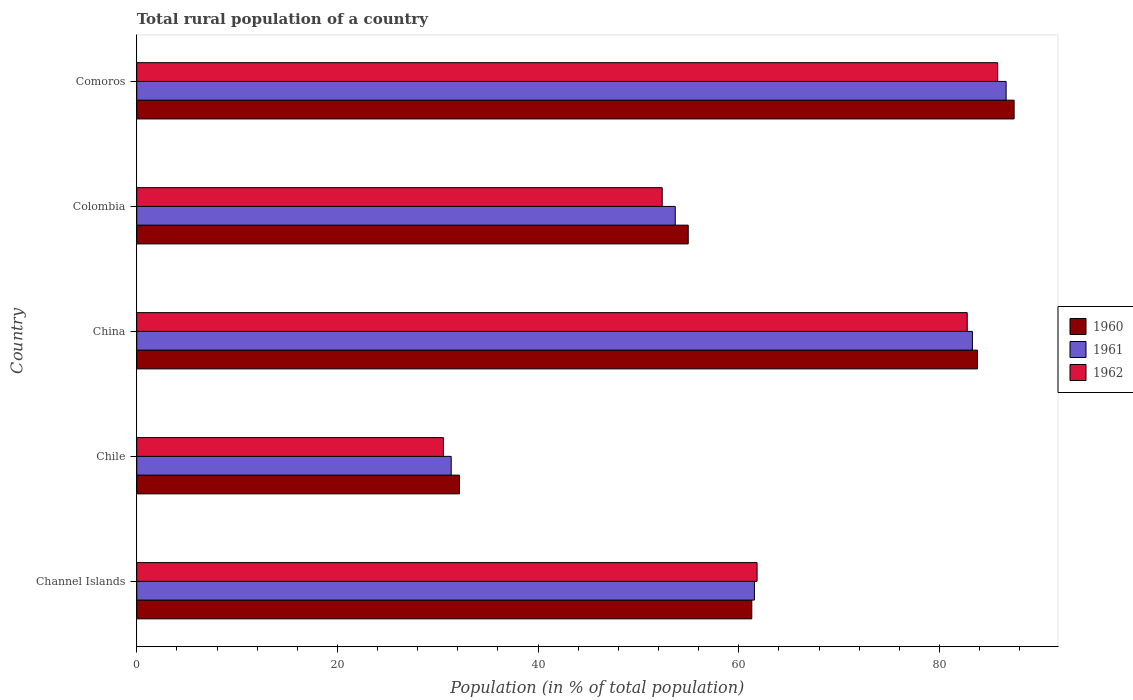Are the number of bars on each tick of the Y-axis equal?
Your answer should be compact. Yes. How many bars are there on the 2nd tick from the top?
Offer a very short reply. 3. How many bars are there on the 5th tick from the bottom?
Ensure brevity in your answer.  3. What is the label of the 2nd group of bars from the top?
Offer a terse response. Colombia. In how many cases, is the number of bars for a given country not equal to the number of legend labels?
Offer a very short reply. 0. What is the rural population in 1960 in China?
Provide a succinct answer. 83.8. Across all countries, what is the maximum rural population in 1960?
Ensure brevity in your answer.  87.45. Across all countries, what is the minimum rural population in 1960?
Provide a short and direct response. 32.16. In which country was the rural population in 1962 maximum?
Provide a short and direct response. Comoros. In which country was the rural population in 1961 minimum?
Your answer should be very brief. Chile. What is the total rural population in 1961 in the graph?
Keep it short and to the point. 316.52. What is the difference between the rural population in 1962 in Channel Islands and that in Colombia?
Your response must be concise. 9.46. What is the difference between the rural population in 1960 in China and the rural population in 1961 in Chile?
Your response must be concise. 52.46. What is the average rural population in 1960 per country?
Make the answer very short. 63.94. What is the difference between the rural population in 1960 and rural population in 1961 in Colombia?
Offer a terse response. 1.29. In how many countries, is the rural population in 1961 greater than 60 %?
Make the answer very short. 3. What is the ratio of the rural population in 1962 in Colombia to that in Comoros?
Your answer should be compact. 0.61. Is the rural population in 1962 in Chile less than that in Colombia?
Ensure brevity in your answer.  Yes. Is the difference between the rural population in 1960 in Channel Islands and Chile greater than the difference between the rural population in 1961 in Channel Islands and Chile?
Keep it short and to the point. No. What is the difference between the highest and the second highest rural population in 1961?
Your response must be concise. 3.36. What is the difference between the highest and the lowest rural population in 1960?
Your answer should be compact. 55.28. What is the difference between two consecutive major ticks on the X-axis?
Keep it short and to the point. 20. How many legend labels are there?
Offer a very short reply. 3. How are the legend labels stacked?
Your answer should be compact. Vertical. What is the title of the graph?
Your answer should be very brief. Total rural population of a country. What is the label or title of the X-axis?
Offer a very short reply. Population (in % of total population). What is the label or title of the Y-axis?
Your answer should be very brief. Country. What is the Population (in % of total population) of 1960 in Channel Islands?
Give a very brief answer. 61.3. What is the Population (in % of total population) of 1961 in Channel Islands?
Make the answer very short. 61.56. What is the Population (in % of total population) in 1962 in Channel Islands?
Offer a terse response. 61.83. What is the Population (in % of total population) of 1960 in Chile?
Make the answer very short. 32.16. What is the Population (in % of total population) in 1961 in Chile?
Offer a terse response. 31.34. What is the Population (in % of total population) of 1962 in Chile?
Your answer should be compact. 30.57. What is the Population (in % of total population) of 1960 in China?
Make the answer very short. 83.8. What is the Population (in % of total population) of 1961 in China?
Offer a very short reply. 83.29. What is the Population (in % of total population) in 1962 in China?
Provide a succinct answer. 82.77. What is the Population (in % of total population) of 1960 in Colombia?
Make the answer very short. 54.97. What is the Population (in % of total population) in 1961 in Colombia?
Offer a terse response. 53.67. What is the Population (in % of total population) of 1962 in Colombia?
Provide a short and direct response. 52.37. What is the Population (in % of total population) of 1960 in Comoros?
Offer a terse response. 87.45. What is the Population (in % of total population) in 1961 in Comoros?
Make the answer very short. 86.65. What is the Population (in % of total population) of 1962 in Comoros?
Offer a very short reply. 85.81. Across all countries, what is the maximum Population (in % of total population) of 1960?
Your response must be concise. 87.45. Across all countries, what is the maximum Population (in % of total population) of 1961?
Keep it short and to the point. 86.65. Across all countries, what is the maximum Population (in % of total population) in 1962?
Your response must be concise. 85.81. Across all countries, what is the minimum Population (in % of total population) in 1960?
Make the answer very short. 32.16. Across all countries, what is the minimum Population (in % of total population) in 1961?
Your response must be concise. 31.34. Across all countries, what is the minimum Population (in % of total population) in 1962?
Offer a very short reply. 30.57. What is the total Population (in % of total population) of 1960 in the graph?
Ensure brevity in your answer.  319.68. What is the total Population (in % of total population) of 1961 in the graph?
Offer a terse response. 316.52. What is the total Population (in % of total population) of 1962 in the graph?
Give a very brief answer. 313.35. What is the difference between the Population (in % of total population) in 1960 in Channel Islands and that in Chile?
Provide a succinct answer. 29.14. What is the difference between the Population (in % of total population) in 1961 in Channel Islands and that in Chile?
Keep it short and to the point. 30.22. What is the difference between the Population (in % of total population) in 1962 in Channel Islands and that in Chile?
Provide a succinct answer. 31.26. What is the difference between the Population (in % of total population) in 1960 in Channel Islands and that in China?
Offer a terse response. -22.5. What is the difference between the Population (in % of total population) of 1961 in Channel Islands and that in China?
Your response must be concise. -21.73. What is the difference between the Population (in % of total population) of 1962 in Channel Islands and that in China?
Keep it short and to the point. -20.95. What is the difference between the Population (in % of total population) in 1960 in Channel Islands and that in Colombia?
Ensure brevity in your answer.  6.33. What is the difference between the Population (in % of total population) of 1961 in Channel Islands and that in Colombia?
Offer a very short reply. 7.89. What is the difference between the Population (in % of total population) of 1962 in Channel Islands and that in Colombia?
Provide a succinct answer. 9.46. What is the difference between the Population (in % of total population) of 1960 in Channel Islands and that in Comoros?
Your answer should be very brief. -26.15. What is the difference between the Population (in % of total population) in 1961 in Channel Islands and that in Comoros?
Ensure brevity in your answer.  -25.09. What is the difference between the Population (in % of total population) in 1962 in Channel Islands and that in Comoros?
Provide a short and direct response. -23.98. What is the difference between the Population (in % of total population) in 1960 in Chile and that in China?
Offer a very short reply. -51.63. What is the difference between the Population (in % of total population) of 1961 in Chile and that in China?
Your answer should be very brief. -51.95. What is the difference between the Population (in % of total population) of 1962 in Chile and that in China?
Your answer should be very brief. -52.21. What is the difference between the Population (in % of total population) of 1960 in Chile and that in Colombia?
Make the answer very short. -22.8. What is the difference between the Population (in % of total population) in 1961 in Chile and that in Colombia?
Your response must be concise. -22.33. What is the difference between the Population (in % of total population) in 1962 in Chile and that in Colombia?
Your response must be concise. -21.81. What is the difference between the Population (in % of total population) of 1960 in Chile and that in Comoros?
Make the answer very short. -55.28. What is the difference between the Population (in % of total population) of 1961 in Chile and that in Comoros?
Ensure brevity in your answer.  -55.31. What is the difference between the Population (in % of total population) in 1962 in Chile and that in Comoros?
Keep it short and to the point. -55.25. What is the difference between the Population (in % of total population) in 1960 in China and that in Colombia?
Your answer should be compact. 28.83. What is the difference between the Population (in % of total population) of 1961 in China and that in Colombia?
Offer a terse response. 29.62. What is the difference between the Population (in % of total population) in 1962 in China and that in Colombia?
Provide a short and direct response. 30.4. What is the difference between the Population (in % of total population) in 1960 in China and that in Comoros?
Your answer should be very brief. -3.65. What is the difference between the Population (in % of total population) of 1961 in China and that in Comoros?
Your answer should be compact. -3.36. What is the difference between the Population (in % of total population) of 1962 in China and that in Comoros?
Make the answer very short. -3.04. What is the difference between the Population (in % of total population) in 1960 in Colombia and that in Comoros?
Your response must be concise. -32.48. What is the difference between the Population (in % of total population) of 1961 in Colombia and that in Comoros?
Keep it short and to the point. -32.98. What is the difference between the Population (in % of total population) in 1962 in Colombia and that in Comoros?
Provide a short and direct response. -33.44. What is the difference between the Population (in % of total population) of 1960 in Channel Islands and the Population (in % of total population) of 1961 in Chile?
Provide a short and direct response. 29.96. What is the difference between the Population (in % of total population) in 1960 in Channel Islands and the Population (in % of total population) in 1962 in Chile?
Offer a terse response. 30.73. What is the difference between the Population (in % of total population) in 1961 in Channel Islands and the Population (in % of total population) in 1962 in Chile?
Your response must be concise. 31. What is the difference between the Population (in % of total population) in 1960 in Channel Islands and the Population (in % of total population) in 1961 in China?
Keep it short and to the point. -21.99. What is the difference between the Population (in % of total population) in 1960 in Channel Islands and the Population (in % of total population) in 1962 in China?
Offer a terse response. -21.47. What is the difference between the Population (in % of total population) in 1961 in Channel Islands and the Population (in % of total population) in 1962 in China?
Your response must be concise. -21.21. What is the difference between the Population (in % of total population) in 1960 in Channel Islands and the Population (in % of total population) in 1961 in Colombia?
Offer a very short reply. 7.63. What is the difference between the Population (in % of total population) in 1960 in Channel Islands and the Population (in % of total population) in 1962 in Colombia?
Provide a short and direct response. 8.93. What is the difference between the Population (in % of total population) of 1961 in Channel Islands and the Population (in % of total population) of 1962 in Colombia?
Provide a succinct answer. 9.19. What is the difference between the Population (in % of total population) in 1960 in Channel Islands and the Population (in % of total population) in 1961 in Comoros?
Your answer should be compact. -25.35. What is the difference between the Population (in % of total population) in 1960 in Channel Islands and the Population (in % of total population) in 1962 in Comoros?
Keep it short and to the point. -24.51. What is the difference between the Population (in % of total population) in 1961 in Channel Islands and the Population (in % of total population) in 1962 in Comoros?
Ensure brevity in your answer.  -24.25. What is the difference between the Population (in % of total population) in 1960 in Chile and the Population (in % of total population) in 1961 in China?
Provide a short and direct response. -51.13. What is the difference between the Population (in % of total population) in 1960 in Chile and the Population (in % of total population) in 1962 in China?
Offer a terse response. -50.61. What is the difference between the Population (in % of total population) of 1961 in Chile and the Population (in % of total population) of 1962 in China?
Give a very brief answer. -51.43. What is the difference between the Population (in % of total population) in 1960 in Chile and the Population (in % of total population) in 1961 in Colombia?
Make the answer very short. -21.51. What is the difference between the Population (in % of total population) in 1960 in Chile and the Population (in % of total population) in 1962 in Colombia?
Your response must be concise. -20.21. What is the difference between the Population (in % of total population) of 1961 in Chile and the Population (in % of total population) of 1962 in Colombia?
Give a very brief answer. -21.03. What is the difference between the Population (in % of total population) of 1960 in Chile and the Population (in % of total population) of 1961 in Comoros?
Ensure brevity in your answer.  -54.49. What is the difference between the Population (in % of total population) of 1960 in Chile and the Population (in % of total population) of 1962 in Comoros?
Make the answer very short. -53.65. What is the difference between the Population (in % of total population) of 1961 in Chile and the Population (in % of total population) of 1962 in Comoros?
Give a very brief answer. -54.47. What is the difference between the Population (in % of total population) of 1960 in China and the Population (in % of total population) of 1961 in Colombia?
Your response must be concise. 30.12. What is the difference between the Population (in % of total population) of 1960 in China and the Population (in % of total population) of 1962 in Colombia?
Offer a very short reply. 31.43. What is the difference between the Population (in % of total population) of 1961 in China and the Population (in % of total population) of 1962 in Colombia?
Provide a short and direct response. 30.92. What is the difference between the Population (in % of total population) of 1960 in China and the Population (in % of total population) of 1961 in Comoros?
Provide a short and direct response. -2.85. What is the difference between the Population (in % of total population) of 1960 in China and the Population (in % of total population) of 1962 in Comoros?
Provide a succinct answer. -2.01. What is the difference between the Population (in % of total population) in 1961 in China and the Population (in % of total population) in 1962 in Comoros?
Your response must be concise. -2.52. What is the difference between the Population (in % of total population) of 1960 in Colombia and the Population (in % of total population) of 1961 in Comoros?
Your response must be concise. -31.68. What is the difference between the Population (in % of total population) of 1960 in Colombia and the Population (in % of total population) of 1962 in Comoros?
Ensure brevity in your answer.  -30.84. What is the difference between the Population (in % of total population) in 1961 in Colombia and the Population (in % of total population) in 1962 in Comoros?
Make the answer very short. -32.14. What is the average Population (in % of total population) in 1960 per country?
Provide a short and direct response. 63.94. What is the average Population (in % of total population) in 1961 per country?
Your answer should be compact. 63.3. What is the average Population (in % of total population) in 1962 per country?
Ensure brevity in your answer.  62.67. What is the difference between the Population (in % of total population) in 1960 and Population (in % of total population) in 1961 in Channel Islands?
Your answer should be very brief. -0.26. What is the difference between the Population (in % of total population) of 1960 and Population (in % of total population) of 1962 in Channel Islands?
Ensure brevity in your answer.  -0.53. What is the difference between the Population (in % of total population) of 1961 and Population (in % of total population) of 1962 in Channel Islands?
Give a very brief answer. -0.26. What is the difference between the Population (in % of total population) in 1960 and Population (in % of total population) in 1961 in Chile?
Your response must be concise. 0.82. What is the difference between the Population (in % of total population) of 1960 and Population (in % of total population) of 1962 in Chile?
Provide a short and direct response. 1.6. What is the difference between the Population (in % of total population) of 1961 and Population (in % of total population) of 1962 in Chile?
Make the answer very short. 0.78. What is the difference between the Population (in % of total population) of 1960 and Population (in % of total population) of 1961 in China?
Make the answer very short. 0.51. What is the difference between the Population (in % of total population) in 1961 and Population (in % of total population) in 1962 in China?
Ensure brevity in your answer.  0.52. What is the difference between the Population (in % of total population) in 1960 and Population (in % of total population) in 1961 in Colombia?
Your answer should be compact. 1.29. What is the difference between the Population (in % of total population) in 1960 and Population (in % of total population) in 1962 in Colombia?
Your response must be concise. 2.6. What is the difference between the Population (in % of total population) in 1961 and Population (in % of total population) in 1962 in Colombia?
Your answer should be very brief. 1.3. What is the difference between the Population (in % of total population) in 1960 and Population (in % of total population) in 1961 in Comoros?
Offer a terse response. 0.8. What is the difference between the Population (in % of total population) in 1960 and Population (in % of total population) in 1962 in Comoros?
Your answer should be very brief. 1.64. What is the difference between the Population (in % of total population) in 1961 and Population (in % of total population) in 1962 in Comoros?
Make the answer very short. 0.84. What is the ratio of the Population (in % of total population) of 1960 in Channel Islands to that in Chile?
Make the answer very short. 1.91. What is the ratio of the Population (in % of total population) in 1961 in Channel Islands to that in Chile?
Your answer should be very brief. 1.96. What is the ratio of the Population (in % of total population) of 1962 in Channel Islands to that in Chile?
Give a very brief answer. 2.02. What is the ratio of the Population (in % of total population) of 1960 in Channel Islands to that in China?
Offer a very short reply. 0.73. What is the ratio of the Population (in % of total population) of 1961 in Channel Islands to that in China?
Provide a short and direct response. 0.74. What is the ratio of the Population (in % of total population) in 1962 in Channel Islands to that in China?
Offer a very short reply. 0.75. What is the ratio of the Population (in % of total population) of 1960 in Channel Islands to that in Colombia?
Offer a very short reply. 1.12. What is the ratio of the Population (in % of total population) of 1961 in Channel Islands to that in Colombia?
Offer a terse response. 1.15. What is the ratio of the Population (in % of total population) of 1962 in Channel Islands to that in Colombia?
Keep it short and to the point. 1.18. What is the ratio of the Population (in % of total population) of 1960 in Channel Islands to that in Comoros?
Your answer should be compact. 0.7. What is the ratio of the Population (in % of total population) of 1961 in Channel Islands to that in Comoros?
Your answer should be very brief. 0.71. What is the ratio of the Population (in % of total population) in 1962 in Channel Islands to that in Comoros?
Provide a short and direct response. 0.72. What is the ratio of the Population (in % of total population) of 1960 in Chile to that in China?
Your answer should be very brief. 0.38. What is the ratio of the Population (in % of total population) in 1961 in Chile to that in China?
Your response must be concise. 0.38. What is the ratio of the Population (in % of total population) in 1962 in Chile to that in China?
Your response must be concise. 0.37. What is the ratio of the Population (in % of total population) in 1960 in Chile to that in Colombia?
Your answer should be very brief. 0.59. What is the ratio of the Population (in % of total population) of 1961 in Chile to that in Colombia?
Keep it short and to the point. 0.58. What is the ratio of the Population (in % of total population) in 1962 in Chile to that in Colombia?
Your answer should be very brief. 0.58. What is the ratio of the Population (in % of total population) of 1960 in Chile to that in Comoros?
Provide a short and direct response. 0.37. What is the ratio of the Population (in % of total population) of 1961 in Chile to that in Comoros?
Make the answer very short. 0.36. What is the ratio of the Population (in % of total population) in 1962 in Chile to that in Comoros?
Keep it short and to the point. 0.36. What is the ratio of the Population (in % of total population) of 1960 in China to that in Colombia?
Keep it short and to the point. 1.52. What is the ratio of the Population (in % of total population) of 1961 in China to that in Colombia?
Give a very brief answer. 1.55. What is the ratio of the Population (in % of total population) in 1962 in China to that in Colombia?
Your answer should be very brief. 1.58. What is the ratio of the Population (in % of total population) of 1960 in China to that in Comoros?
Give a very brief answer. 0.96. What is the ratio of the Population (in % of total population) of 1961 in China to that in Comoros?
Ensure brevity in your answer.  0.96. What is the ratio of the Population (in % of total population) in 1962 in China to that in Comoros?
Your response must be concise. 0.96. What is the ratio of the Population (in % of total population) of 1960 in Colombia to that in Comoros?
Give a very brief answer. 0.63. What is the ratio of the Population (in % of total population) in 1961 in Colombia to that in Comoros?
Give a very brief answer. 0.62. What is the ratio of the Population (in % of total population) of 1962 in Colombia to that in Comoros?
Provide a short and direct response. 0.61. What is the difference between the highest and the second highest Population (in % of total population) in 1960?
Provide a succinct answer. 3.65. What is the difference between the highest and the second highest Population (in % of total population) in 1961?
Provide a succinct answer. 3.36. What is the difference between the highest and the second highest Population (in % of total population) of 1962?
Give a very brief answer. 3.04. What is the difference between the highest and the lowest Population (in % of total population) in 1960?
Ensure brevity in your answer.  55.28. What is the difference between the highest and the lowest Population (in % of total population) of 1961?
Offer a very short reply. 55.31. What is the difference between the highest and the lowest Population (in % of total population) in 1962?
Provide a succinct answer. 55.25. 